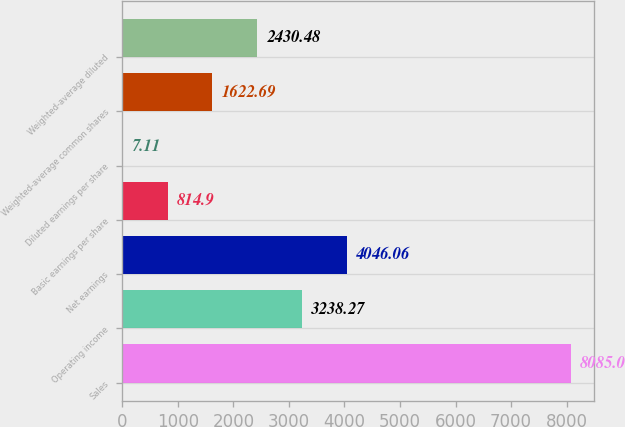<chart> <loc_0><loc_0><loc_500><loc_500><bar_chart><fcel>Sales<fcel>Operating income<fcel>Net earnings<fcel>Basic earnings per share<fcel>Diluted earnings per share<fcel>Weighted-average common shares<fcel>Weighted-average diluted<nl><fcel>8085<fcel>3238.27<fcel>4046.06<fcel>814.9<fcel>7.11<fcel>1622.69<fcel>2430.48<nl></chart> 